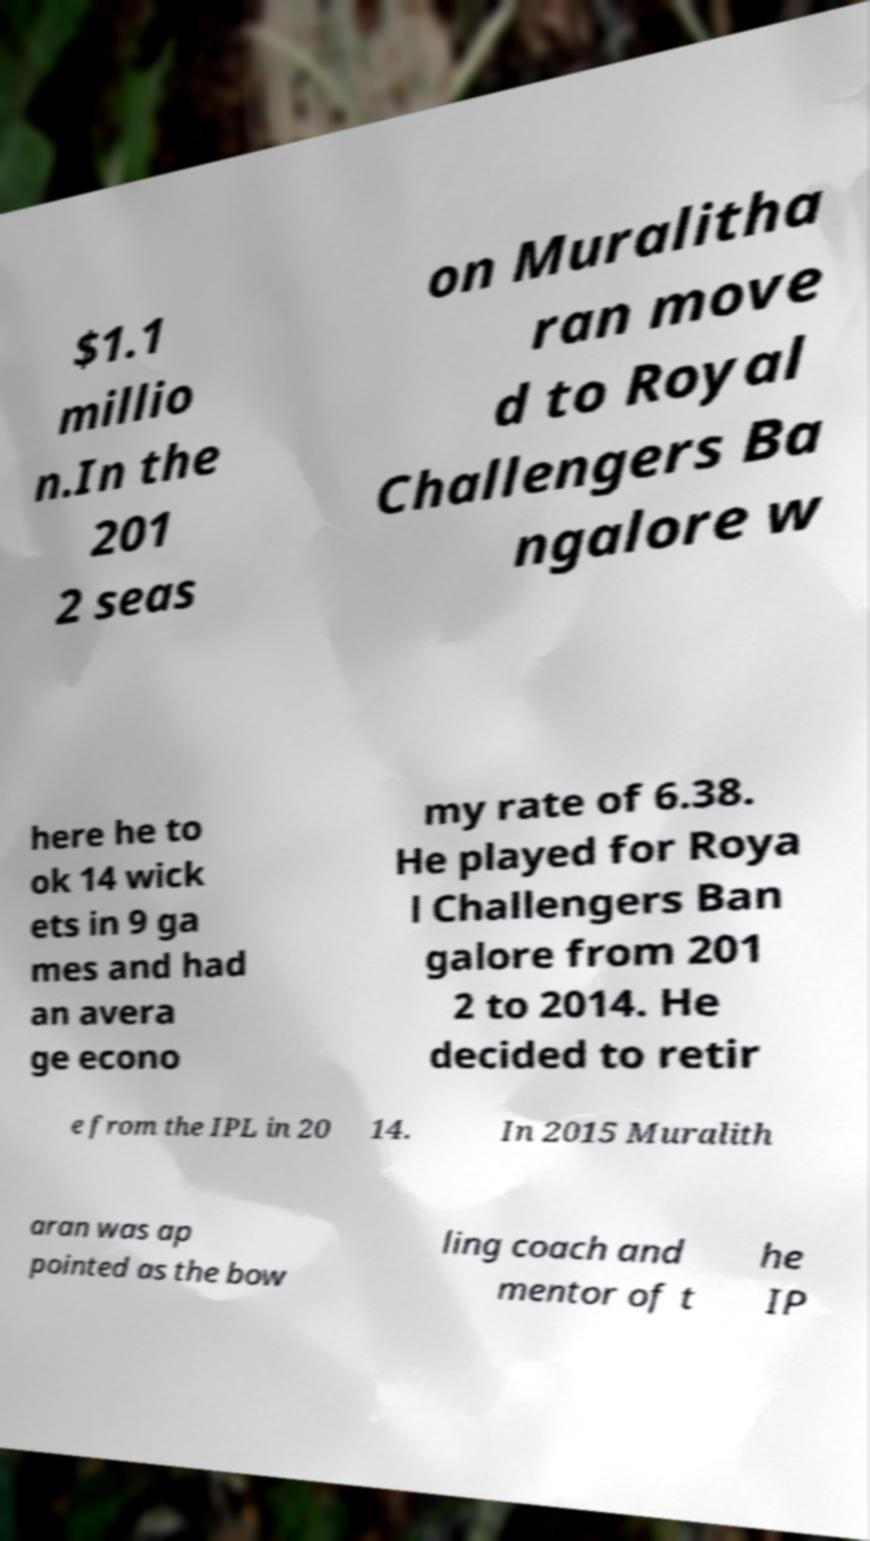Could you assist in decoding the text presented in this image and type it out clearly? $1.1 millio n.In the 201 2 seas on Muralitha ran move d to Royal Challengers Ba ngalore w here he to ok 14 wick ets in 9 ga mes and had an avera ge econo my rate of 6.38. He played for Roya l Challengers Ban galore from 201 2 to 2014. He decided to retir e from the IPL in 20 14. In 2015 Muralith aran was ap pointed as the bow ling coach and mentor of t he IP 